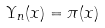<formula> <loc_0><loc_0><loc_500><loc_500>\Upsilon _ { n } ( x ) = \pi ( x )</formula> 